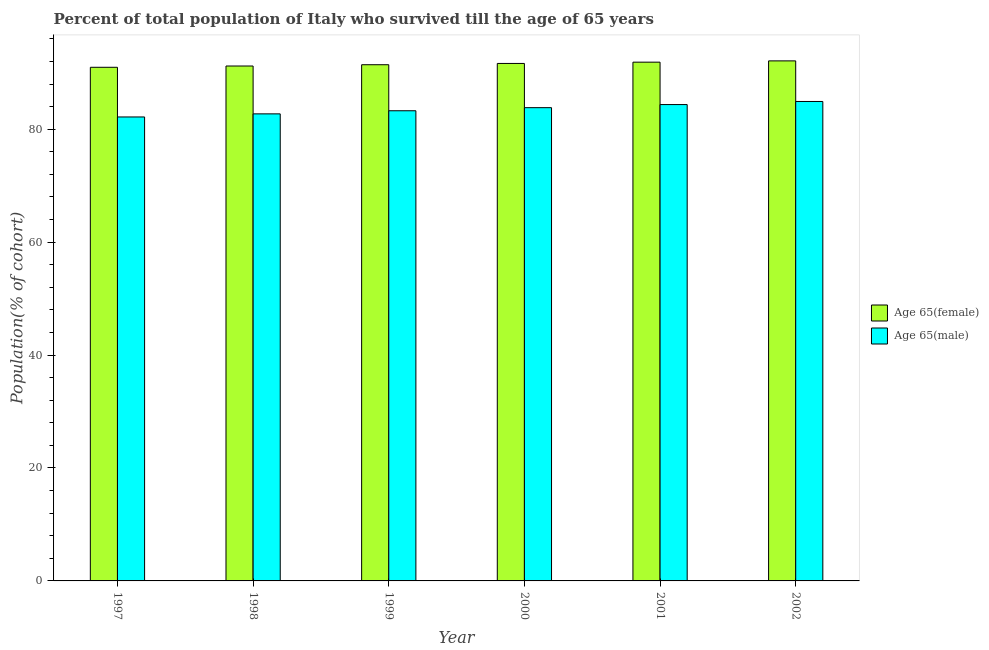How many different coloured bars are there?
Offer a very short reply. 2. Are the number of bars on each tick of the X-axis equal?
Give a very brief answer. Yes. How many bars are there on the 1st tick from the left?
Offer a terse response. 2. In how many cases, is the number of bars for a given year not equal to the number of legend labels?
Offer a very short reply. 0. What is the percentage of male population who survived till age of 65 in 2002?
Offer a terse response. 84.91. Across all years, what is the maximum percentage of male population who survived till age of 65?
Your response must be concise. 84.91. Across all years, what is the minimum percentage of female population who survived till age of 65?
Keep it short and to the point. 90.96. In which year was the percentage of female population who survived till age of 65 minimum?
Ensure brevity in your answer.  1997. What is the total percentage of female population who survived till age of 65 in the graph?
Provide a succinct answer. 549.17. What is the difference between the percentage of female population who survived till age of 65 in 2000 and that in 2001?
Your response must be concise. -0.23. What is the difference between the percentage of male population who survived till age of 65 in 1998 and the percentage of female population who survived till age of 65 in 2002?
Your answer should be compact. -2.19. What is the average percentage of male population who survived till age of 65 per year?
Your answer should be compact. 83.54. In the year 1998, what is the difference between the percentage of female population who survived till age of 65 and percentage of male population who survived till age of 65?
Offer a very short reply. 0. In how many years, is the percentage of female population who survived till age of 65 greater than 36 %?
Provide a short and direct response. 6. What is the ratio of the percentage of female population who survived till age of 65 in 1997 to that in 2001?
Your answer should be very brief. 0.99. Is the percentage of female population who survived till age of 65 in 1997 less than that in 2002?
Your answer should be compact. Yes. What is the difference between the highest and the second highest percentage of male population who survived till age of 65?
Your response must be concise. 0.55. What is the difference between the highest and the lowest percentage of male population who survived till age of 65?
Your answer should be compact. 2.74. Is the sum of the percentage of male population who survived till age of 65 in 1999 and 2001 greater than the maximum percentage of female population who survived till age of 65 across all years?
Keep it short and to the point. Yes. What does the 2nd bar from the left in 1998 represents?
Give a very brief answer. Age 65(male). What does the 1st bar from the right in 2001 represents?
Keep it short and to the point. Age 65(male). Are all the bars in the graph horizontal?
Provide a succinct answer. No. How many years are there in the graph?
Your answer should be very brief. 6. Are the values on the major ticks of Y-axis written in scientific E-notation?
Make the answer very short. No. How many legend labels are there?
Keep it short and to the point. 2. How are the legend labels stacked?
Keep it short and to the point. Vertical. What is the title of the graph?
Give a very brief answer. Percent of total population of Italy who survived till the age of 65 years. What is the label or title of the Y-axis?
Ensure brevity in your answer.  Population(% of cohort). What is the Population(% of cohort) in Age 65(female) in 1997?
Your answer should be very brief. 90.96. What is the Population(% of cohort) in Age 65(male) in 1997?
Offer a very short reply. 82.17. What is the Population(% of cohort) of Age 65(female) in 1998?
Your response must be concise. 91.19. What is the Population(% of cohort) of Age 65(male) in 1998?
Offer a terse response. 82.71. What is the Population(% of cohort) in Age 65(female) in 1999?
Ensure brevity in your answer.  91.41. What is the Population(% of cohort) of Age 65(male) in 1999?
Provide a short and direct response. 83.26. What is the Population(% of cohort) in Age 65(female) in 2000?
Your response must be concise. 91.64. What is the Population(% of cohort) of Age 65(male) in 2000?
Offer a very short reply. 83.81. What is the Population(% of cohort) in Age 65(female) in 2001?
Your answer should be very brief. 91.87. What is the Population(% of cohort) of Age 65(male) in 2001?
Your response must be concise. 84.36. What is the Population(% of cohort) of Age 65(female) in 2002?
Your answer should be compact. 92.1. What is the Population(% of cohort) in Age 65(male) in 2002?
Ensure brevity in your answer.  84.91. Across all years, what is the maximum Population(% of cohort) in Age 65(female)?
Your answer should be very brief. 92.1. Across all years, what is the maximum Population(% of cohort) in Age 65(male)?
Your answer should be compact. 84.91. Across all years, what is the minimum Population(% of cohort) in Age 65(female)?
Provide a short and direct response. 90.96. Across all years, what is the minimum Population(% of cohort) in Age 65(male)?
Give a very brief answer. 82.17. What is the total Population(% of cohort) of Age 65(female) in the graph?
Offer a terse response. 549.17. What is the total Population(% of cohort) in Age 65(male) in the graph?
Offer a terse response. 501.21. What is the difference between the Population(% of cohort) in Age 65(female) in 1997 and that in 1998?
Your response must be concise. -0.23. What is the difference between the Population(% of cohort) in Age 65(male) in 1997 and that in 1998?
Ensure brevity in your answer.  -0.55. What is the difference between the Population(% of cohort) in Age 65(female) in 1997 and that in 1999?
Ensure brevity in your answer.  -0.45. What is the difference between the Population(% of cohort) in Age 65(male) in 1997 and that in 1999?
Keep it short and to the point. -1.1. What is the difference between the Population(% of cohort) of Age 65(female) in 1997 and that in 2000?
Keep it short and to the point. -0.68. What is the difference between the Population(% of cohort) in Age 65(male) in 1997 and that in 2000?
Your answer should be compact. -1.64. What is the difference between the Population(% of cohort) of Age 65(female) in 1997 and that in 2001?
Provide a succinct answer. -0.91. What is the difference between the Population(% of cohort) of Age 65(male) in 1997 and that in 2001?
Keep it short and to the point. -2.19. What is the difference between the Population(% of cohort) in Age 65(female) in 1997 and that in 2002?
Offer a terse response. -1.14. What is the difference between the Population(% of cohort) in Age 65(male) in 1997 and that in 2002?
Offer a terse response. -2.74. What is the difference between the Population(% of cohort) in Age 65(female) in 1998 and that in 1999?
Provide a succinct answer. -0.23. What is the difference between the Population(% of cohort) of Age 65(male) in 1998 and that in 1999?
Offer a terse response. -0.55. What is the difference between the Population(% of cohort) of Age 65(female) in 1998 and that in 2000?
Provide a short and direct response. -0.45. What is the difference between the Population(% of cohort) in Age 65(male) in 1998 and that in 2000?
Keep it short and to the point. -1.1. What is the difference between the Population(% of cohort) of Age 65(female) in 1998 and that in 2001?
Offer a terse response. -0.68. What is the difference between the Population(% of cohort) of Age 65(male) in 1998 and that in 2001?
Make the answer very short. -1.64. What is the difference between the Population(% of cohort) in Age 65(female) in 1998 and that in 2002?
Provide a short and direct response. -0.91. What is the difference between the Population(% of cohort) in Age 65(male) in 1998 and that in 2002?
Make the answer very short. -2.19. What is the difference between the Population(% of cohort) in Age 65(female) in 1999 and that in 2000?
Ensure brevity in your answer.  -0.23. What is the difference between the Population(% of cohort) in Age 65(male) in 1999 and that in 2000?
Provide a short and direct response. -0.55. What is the difference between the Population(% of cohort) in Age 65(female) in 1999 and that in 2001?
Your answer should be very brief. -0.45. What is the difference between the Population(% of cohort) in Age 65(male) in 1999 and that in 2001?
Ensure brevity in your answer.  -1.1. What is the difference between the Population(% of cohort) in Age 65(female) in 1999 and that in 2002?
Give a very brief answer. -0.68. What is the difference between the Population(% of cohort) in Age 65(male) in 1999 and that in 2002?
Provide a short and direct response. -1.64. What is the difference between the Population(% of cohort) in Age 65(female) in 2000 and that in 2001?
Provide a short and direct response. -0.23. What is the difference between the Population(% of cohort) of Age 65(male) in 2000 and that in 2001?
Make the answer very short. -0.55. What is the difference between the Population(% of cohort) of Age 65(female) in 2000 and that in 2002?
Offer a very short reply. -0.45. What is the difference between the Population(% of cohort) in Age 65(male) in 2000 and that in 2002?
Provide a short and direct response. -1.1. What is the difference between the Population(% of cohort) in Age 65(female) in 2001 and that in 2002?
Your answer should be compact. -0.23. What is the difference between the Population(% of cohort) of Age 65(male) in 2001 and that in 2002?
Keep it short and to the point. -0.55. What is the difference between the Population(% of cohort) in Age 65(female) in 1997 and the Population(% of cohort) in Age 65(male) in 1998?
Keep it short and to the point. 8.25. What is the difference between the Population(% of cohort) of Age 65(female) in 1997 and the Population(% of cohort) of Age 65(male) in 1999?
Your answer should be compact. 7.7. What is the difference between the Population(% of cohort) in Age 65(female) in 1997 and the Population(% of cohort) in Age 65(male) in 2000?
Keep it short and to the point. 7.15. What is the difference between the Population(% of cohort) of Age 65(female) in 1997 and the Population(% of cohort) of Age 65(male) in 2001?
Give a very brief answer. 6.6. What is the difference between the Population(% of cohort) in Age 65(female) in 1997 and the Population(% of cohort) in Age 65(male) in 2002?
Make the answer very short. 6.05. What is the difference between the Population(% of cohort) of Age 65(female) in 1998 and the Population(% of cohort) of Age 65(male) in 1999?
Your answer should be very brief. 7.93. What is the difference between the Population(% of cohort) of Age 65(female) in 1998 and the Population(% of cohort) of Age 65(male) in 2000?
Your answer should be very brief. 7.38. What is the difference between the Population(% of cohort) in Age 65(female) in 1998 and the Population(% of cohort) in Age 65(male) in 2001?
Give a very brief answer. 6.83. What is the difference between the Population(% of cohort) in Age 65(female) in 1998 and the Population(% of cohort) in Age 65(male) in 2002?
Your response must be concise. 6.28. What is the difference between the Population(% of cohort) of Age 65(female) in 1999 and the Population(% of cohort) of Age 65(male) in 2000?
Provide a short and direct response. 7.6. What is the difference between the Population(% of cohort) of Age 65(female) in 1999 and the Population(% of cohort) of Age 65(male) in 2001?
Your answer should be compact. 7.06. What is the difference between the Population(% of cohort) in Age 65(female) in 1999 and the Population(% of cohort) in Age 65(male) in 2002?
Give a very brief answer. 6.51. What is the difference between the Population(% of cohort) in Age 65(female) in 2000 and the Population(% of cohort) in Age 65(male) in 2001?
Provide a succinct answer. 7.28. What is the difference between the Population(% of cohort) of Age 65(female) in 2000 and the Population(% of cohort) of Age 65(male) in 2002?
Give a very brief answer. 6.74. What is the difference between the Population(% of cohort) of Age 65(female) in 2001 and the Population(% of cohort) of Age 65(male) in 2002?
Keep it short and to the point. 6.96. What is the average Population(% of cohort) in Age 65(female) per year?
Ensure brevity in your answer.  91.53. What is the average Population(% of cohort) in Age 65(male) per year?
Provide a succinct answer. 83.54. In the year 1997, what is the difference between the Population(% of cohort) in Age 65(female) and Population(% of cohort) in Age 65(male)?
Your answer should be compact. 8.79. In the year 1998, what is the difference between the Population(% of cohort) in Age 65(female) and Population(% of cohort) in Age 65(male)?
Keep it short and to the point. 8.47. In the year 1999, what is the difference between the Population(% of cohort) of Age 65(female) and Population(% of cohort) of Age 65(male)?
Provide a short and direct response. 8.15. In the year 2000, what is the difference between the Population(% of cohort) of Age 65(female) and Population(% of cohort) of Age 65(male)?
Your response must be concise. 7.83. In the year 2001, what is the difference between the Population(% of cohort) of Age 65(female) and Population(% of cohort) of Age 65(male)?
Your answer should be compact. 7.51. In the year 2002, what is the difference between the Population(% of cohort) in Age 65(female) and Population(% of cohort) in Age 65(male)?
Your answer should be compact. 7.19. What is the ratio of the Population(% of cohort) in Age 65(female) in 1997 to that in 1998?
Provide a short and direct response. 1. What is the ratio of the Population(% of cohort) of Age 65(male) in 1997 to that in 1998?
Make the answer very short. 0.99. What is the ratio of the Population(% of cohort) in Age 65(male) in 1997 to that in 2000?
Give a very brief answer. 0.98. What is the ratio of the Population(% of cohort) in Age 65(female) in 1997 to that in 2001?
Offer a terse response. 0.99. What is the ratio of the Population(% of cohort) of Age 65(male) in 1997 to that in 2001?
Ensure brevity in your answer.  0.97. What is the ratio of the Population(% of cohort) of Age 65(male) in 1997 to that in 2002?
Ensure brevity in your answer.  0.97. What is the ratio of the Population(% of cohort) of Age 65(male) in 1998 to that in 1999?
Offer a very short reply. 0.99. What is the ratio of the Population(% of cohort) in Age 65(male) in 1998 to that in 2000?
Keep it short and to the point. 0.99. What is the ratio of the Population(% of cohort) of Age 65(female) in 1998 to that in 2001?
Keep it short and to the point. 0.99. What is the ratio of the Population(% of cohort) of Age 65(male) in 1998 to that in 2001?
Offer a terse response. 0.98. What is the ratio of the Population(% of cohort) in Age 65(female) in 1998 to that in 2002?
Offer a very short reply. 0.99. What is the ratio of the Population(% of cohort) in Age 65(male) in 1998 to that in 2002?
Your response must be concise. 0.97. What is the ratio of the Population(% of cohort) of Age 65(male) in 1999 to that in 2001?
Give a very brief answer. 0.99. What is the ratio of the Population(% of cohort) in Age 65(female) in 1999 to that in 2002?
Make the answer very short. 0.99. What is the ratio of the Population(% of cohort) in Age 65(male) in 1999 to that in 2002?
Offer a very short reply. 0.98. What is the ratio of the Population(% of cohort) of Age 65(male) in 2000 to that in 2002?
Provide a short and direct response. 0.99. What is the ratio of the Population(% of cohort) in Age 65(female) in 2001 to that in 2002?
Your answer should be very brief. 1. What is the ratio of the Population(% of cohort) in Age 65(male) in 2001 to that in 2002?
Offer a very short reply. 0.99. What is the difference between the highest and the second highest Population(% of cohort) in Age 65(female)?
Give a very brief answer. 0.23. What is the difference between the highest and the second highest Population(% of cohort) in Age 65(male)?
Your answer should be very brief. 0.55. What is the difference between the highest and the lowest Population(% of cohort) in Age 65(female)?
Provide a succinct answer. 1.14. What is the difference between the highest and the lowest Population(% of cohort) in Age 65(male)?
Give a very brief answer. 2.74. 